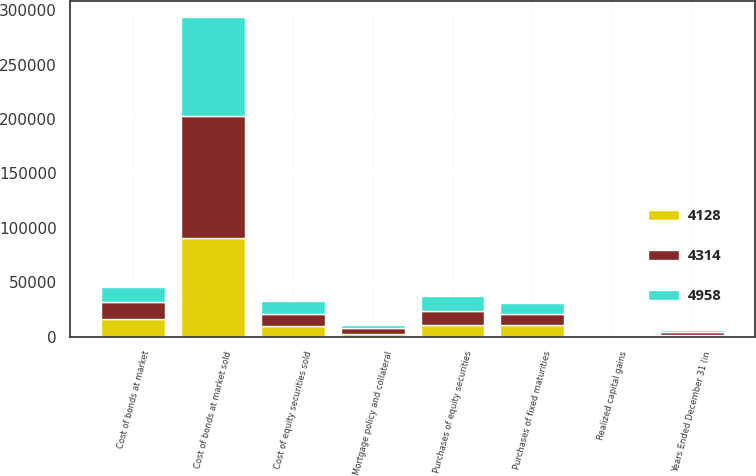Convert chart. <chart><loc_0><loc_0><loc_500><loc_500><stacked_bar_chart><ecel><fcel>Years Ended December 31 (in<fcel>Cost of bonds at market sold<fcel>Cost of bonds at market<fcel>Cost of equity securities sold<fcel>Realized capital gains<fcel>Purchases of fixed maturities<fcel>Purchases of equity securities<fcel>Mortgage policy and collateral<nl><fcel>4314<fcel>2005<fcel>111866<fcel>16017<fcel>11072<fcel>341<fcel>10473<fcel>12972<fcel>5306<nl><fcel>4958<fcel>2004<fcel>91714<fcel>13958<fcel>11711<fcel>44<fcel>10473<fcel>13674<fcel>2128<nl><fcel>4128<fcel>2003<fcel>90430<fcel>15966<fcel>10012<fcel>442<fcel>10473<fcel>10473<fcel>3016<nl></chart> 